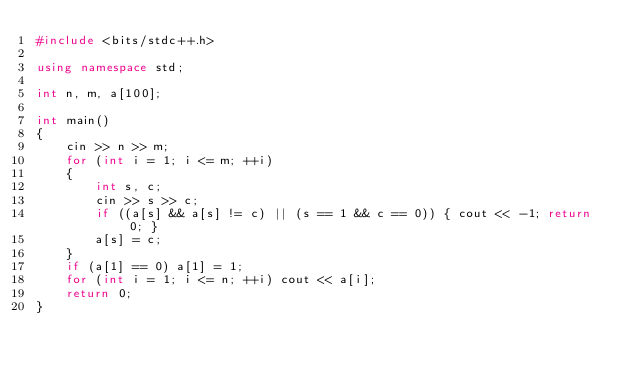<code> <loc_0><loc_0><loc_500><loc_500><_C++_>#include <bits/stdc++.h>

using namespace std;

int n, m, a[100];

int main()
{
    cin >> n >> m;
    for (int i = 1; i <= m; ++i)
    {
        int s, c;
        cin >> s >> c;
        if ((a[s] && a[s] != c) || (s == 1 && c == 0)) { cout << -1; return 0; }
        a[s] = c;
    }
    if (a[1] == 0) a[1] = 1;
    for (int i = 1; i <= n; ++i) cout << a[i];
    return 0;
}
</code> 